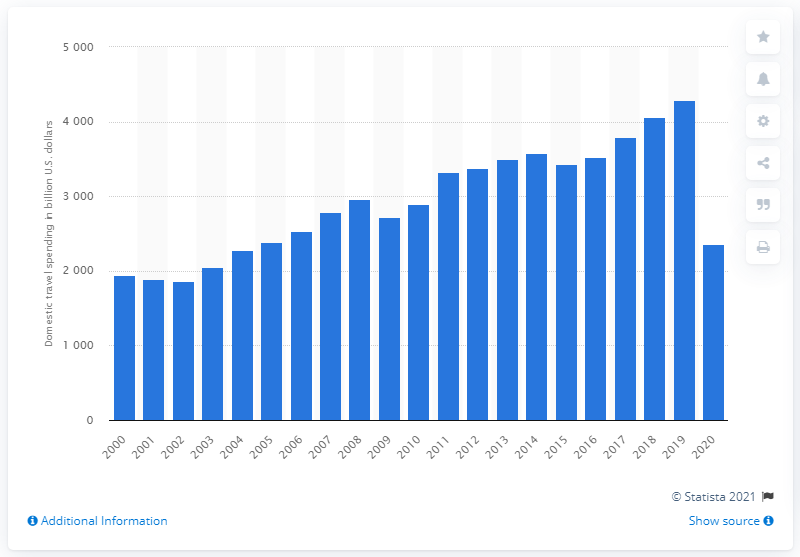Give some essential details in this illustration. According to data from 2019, the amount of domestic tourism spending was approximately 4,295. In 2020, global domestic tourism spending reached approximately 2360. 